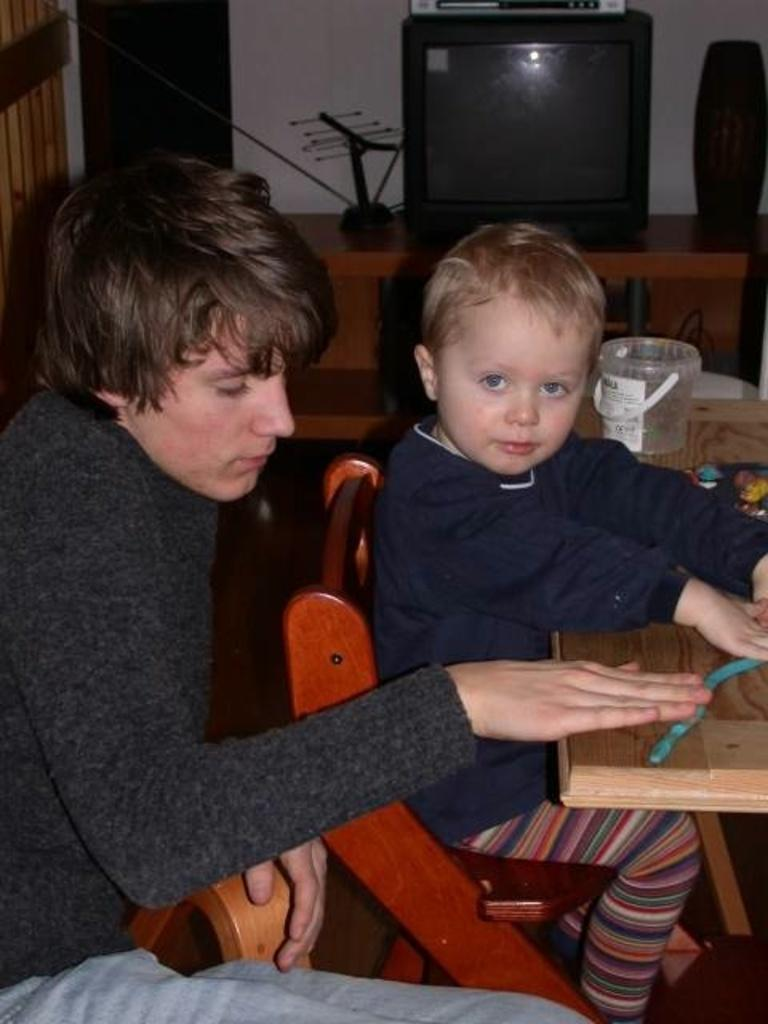What is the child doing in the image? The child is sitting on a chair in the image. Where is the child located in relation to other objects? The child is near a table in the image. Who is sitting behind the child? There is a person sitting behind the child in the image. What can be seen in the background of the image? There is a television in the background of the image. What flavor of truck can be seen in the image? There is no truck present in the image, and therefore no flavor can be associated with it. 